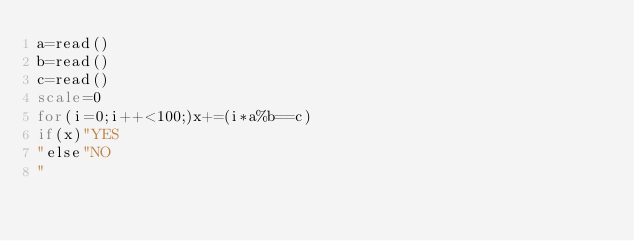Convert code to text. <code><loc_0><loc_0><loc_500><loc_500><_bc_>a=read()
b=read()
c=read()
scale=0
for(i=0;i++<100;)x+=(i*a%b==c)
if(x)"YES
"else"NO
"
</code> 